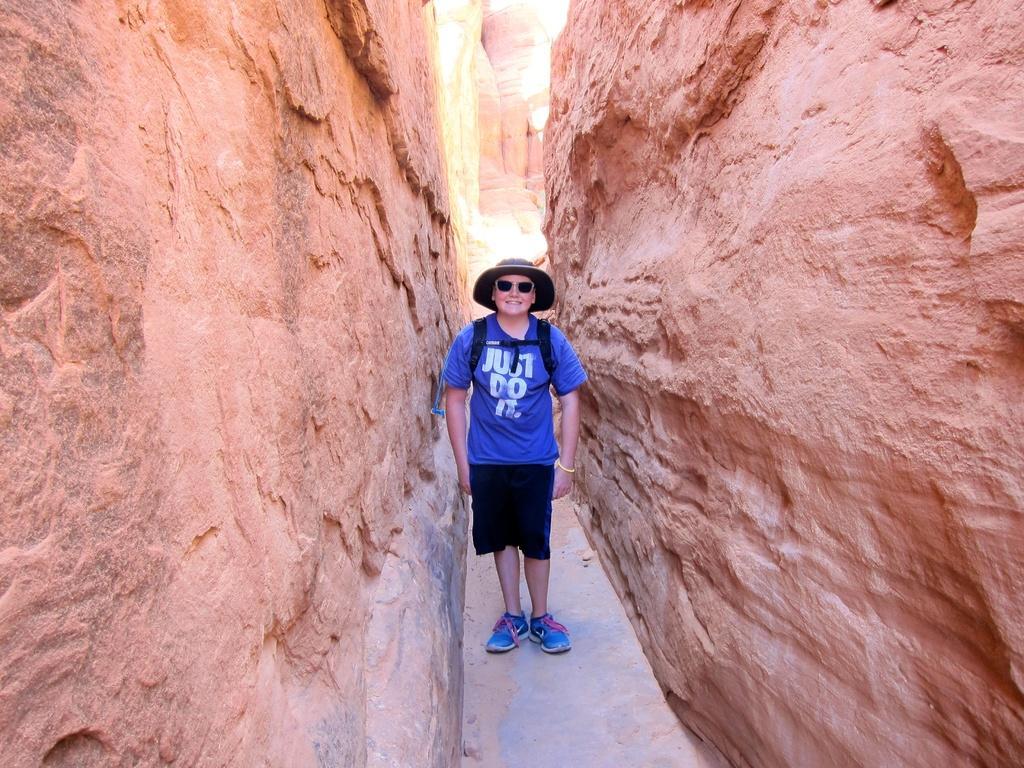In one or two sentences, can you explain what this image depicts? In this image I can see a man wearing blue color t-shirt, black color short, blue color shoes, black color cap on the head,standing, smiling and giving pose for the picture. On both sides of this man I can see the rocks. 